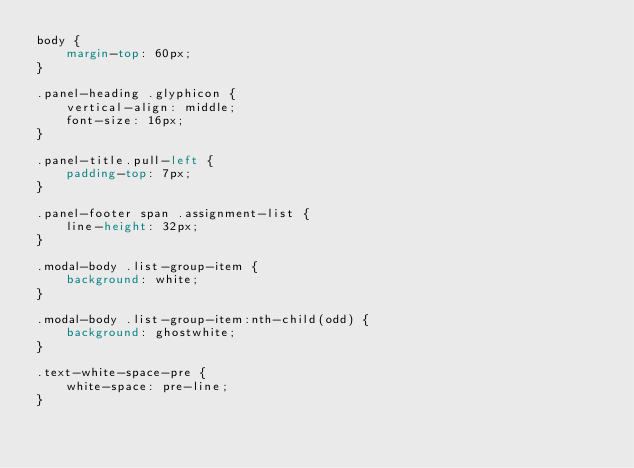Convert code to text. <code><loc_0><loc_0><loc_500><loc_500><_CSS_>body {
    margin-top: 60px;
}

.panel-heading .glyphicon {
    vertical-align: middle;
    font-size: 16px;
}

.panel-title.pull-left {
    padding-top: 7px;
}

.panel-footer span .assignment-list {
    line-height: 32px;
}

.modal-body .list-group-item {
    background: white;
}

.modal-body .list-group-item:nth-child(odd) {
    background: ghostwhite;
}

.text-white-space-pre {
    white-space: pre-line;
}
</code> 